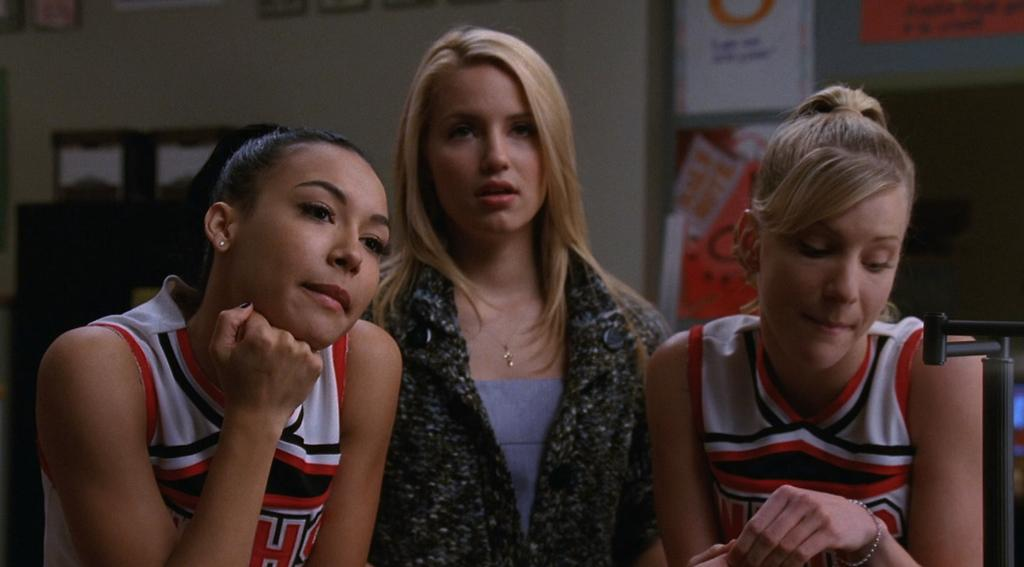<image>
Share a concise interpretation of the image provided. A cheerleader with the letter H on her shirt is with her friends. 